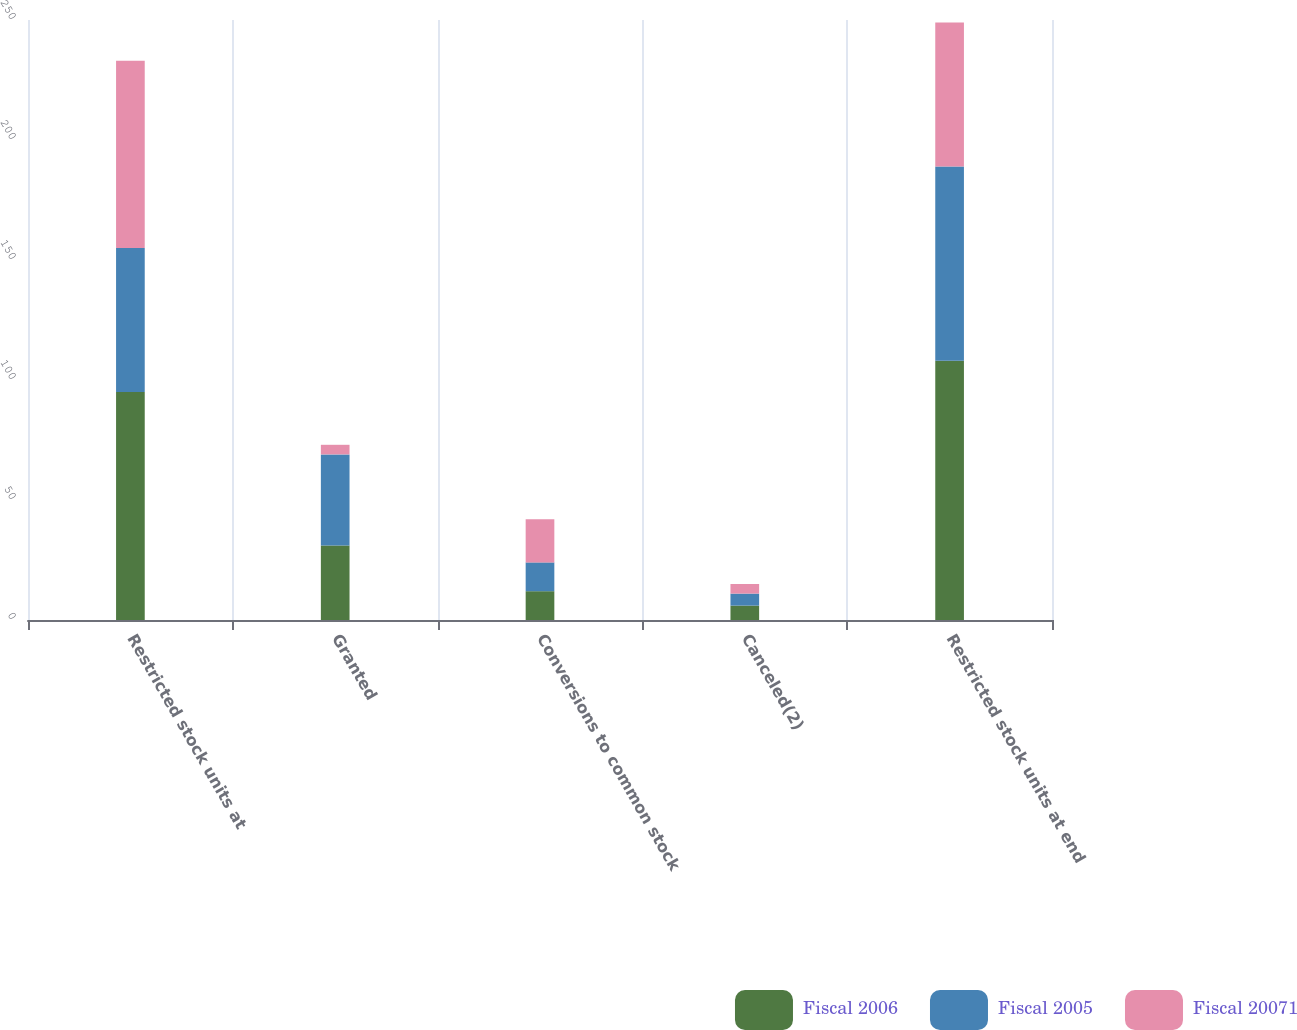<chart> <loc_0><loc_0><loc_500><loc_500><stacked_bar_chart><ecel><fcel>Restricted stock units at<fcel>Granted<fcel>Conversions to common stock<fcel>Canceled(2)<fcel>Restricted stock units at end<nl><fcel>Fiscal 2006<fcel>95<fcel>31<fcel>12<fcel>6<fcel>108<nl><fcel>Fiscal 2005<fcel>60<fcel>38<fcel>12<fcel>5<fcel>81<nl><fcel>Fiscal 20071<fcel>78<fcel>4<fcel>18<fcel>4<fcel>60<nl></chart> 